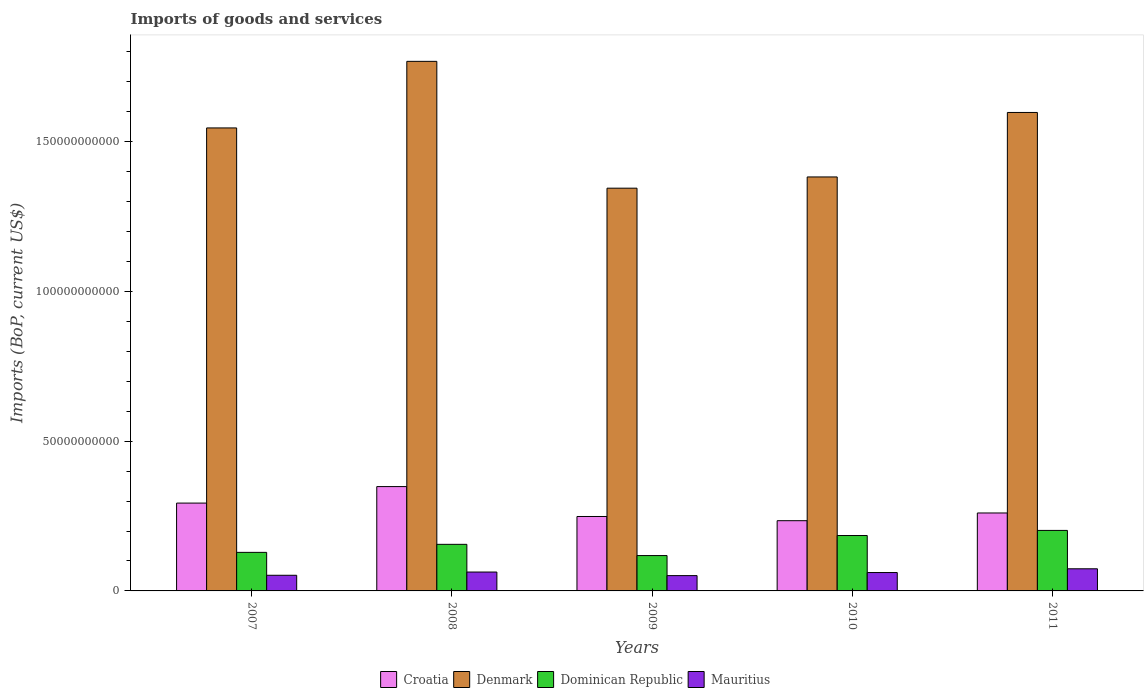Are the number of bars per tick equal to the number of legend labels?
Your response must be concise. Yes. How many bars are there on the 5th tick from the left?
Your answer should be very brief. 4. What is the amount spent on imports in Mauritius in 2011?
Your answer should be very brief. 7.39e+09. Across all years, what is the maximum amount spent on imports in Denmark?
Offer a terse response. 1.77e+11. Across all years, what is the minimum amount spent on imports in Denmark?
Offer a very short reply. 1.34e+11. In which year was the amount spent on imports in Croatia maximum?
Ensure brevity in your answer.  2008. In which year was the amount spent on imports in Denmark minimum?
Offer a very short reply. 2009. What is the total amount spent on imports in Croatia in the graph?
Provide a succinct answer. 1.38e+11. What is the difference between the amount spent on imports in Denmark in 2008 and that in 2011?
Give a very brief answer. 1.71e+1. What is the difference between the amount spent on imports in Dominican Republic in 2007 and the amount spent on imports in Croatia in 2010?
Provide a succinct answer. -1.06e+1. What is the average amount spent on imports in Denmark per year?
Offer a very short reply. 1.53e+11. In the year 2011, what is the difference between the amount spent on imports in Croatia and amount spent on imports in Denmark?
Ensure brevity in your answer.  -1.34e+11. In how many years, is the amount spent on imports in Denmark greater than 10000000000 US$?
Your answer should be compact. 5. What is the ratio of the amount spent on imports in Croatia in 2008 to that in 2010?
Offer a terse response. 1.49. What is the difference between the highest and the second highest amount spent on imports in Croatia?
Provide a succinct answer. 5.50e+09. What is the difference between the highest and the lowest amount spent on imports in Denmark?
Give a very brief answer. 4.23e+1. Is the sum of the amount spent on imports in Denmark in 2007 and 2011 greater than the maximum amount spent on imports in Mauritius across all years?
Your answer should be very brief. Yes. Is it the case that in every year, the sum of the amount spent on imports in Denmark and amount spent on imports in Dominican Republic is greater than the sum of amount spent on imports in Croatia and amount spent on imports in Mauritius?
Ensure brevity in your answer.  No. What does the 4th bar from the left in 2007 represents?
Ensure brevity in your answer.  Mauritius. What does the 1st bar from the right in 2009 represents?
Ensure brevity in your answer.  Mauritius. How many years are there in the graph?
Your answer should be very brief. 5. What is the difference between two consecutive major ticks on the Y-axis?
Provide a succinct answer. 5.00e+1. Are the values on the major ticks of Y-axis written in scientific E-notation?
Offer a terse response. No. Does the graph contain any zero values?
Make the answer very short. No. Where does the legend appear in the graph?
Offer a terse response. Bottom center. How are the legend labels stacked?
Give a very brief answer. Horizontal. What is the title of the graph?
Provide a succinct answer. Imports of goods and services. Does "Cambodia" appear as one of the legend labels in the graph?
Provide a succinct answer. No. What is the label or title of the X-axis?
Provide a succinct answer. Years. What is the label or title of the Y-axis?
Offer a very short reply. Imports (BoP, current US$). What is the Imports (BoP, current US$) in Croatia in 2007?
Your answer should be very brief. 2.93e+1. What is the Imports (BoP, current US$) of Denmark in 2007?
Offer a terse response. 1.55e+11. What is the Imports (BoP, current US$) of Dominican Republic in 2007?
Keep it short and to the point. 1.29e+1. What is the Imports (BoP, current US$) in Mauritius in 2007?
Ensure brevity in your answer.  5.23e+09. What is the Imports (BoP, current US$) of Croatia in 2008?
Your answer should be very brief. 3.48e+1. What is the Imports (BoP, current US$) in Denmark in 2008?
Your response must be concise. 1.77e+11. What is the Imports (BoP, current US$) in Dominican Republic in 2008?
Provide a short and direct response. 1.56e+1. What is the Imports (BoP, current US$) in Mauritius in 2008?
Provide a short and direct response. 6.31e+09. What is the Imports (BoP, current US$) of Croatia in 2009?
Offer a very short reply. 2.48e+1. What is the Imports (BoP, current US$) of Denmark in 2009?
Your answer should be very brief. 1.34e+11. What is the Imports (BoP, current US$) of Dominican Republic in 2009?
Make the answer very short. 1.18e+1. What is the Imports (BoP, current US$) in Mauritius in 2009?
Ensure brevity in your answer.  5.11e+09. What is the Imports (BoP, current US$) in Croatia in 2010?
Offer a terse response. 2.34e+1. What is the Imports (BoP, current US$) of Denmark in 2010?
Provide a succinct answer. 1.38e+11. What is the Imports (BoP, current US$) of Dominican Republic in 2010?
Your response must be concise. 1.85e+1. What is the Imports (BoP, current US$) in Mauritius in 2010?
Ensure brevity in your answer.  6.14e+09. What is the Imports (BoP, current US$) in Croatia in 2011?
Provide a short and direct response. 2.60e+1. What is the Imports (BoP, current US$) of Denmark in 2011?
Offer a very short reply. 1.60e+11. What is the Imports (BoP, current US$) in Dominican Republic in 2011?
Give a very brief answer. 2.02e+1. What is the Imports (BoP, current US$) in Mauritius in 2011?
Provide a short and direct response. 7.39e+09. Across all years, what is the maximum Imports (BoP, current US$) in Croatia?
Your response must be concise. 3.48e+1. Across all years, what is the maximum Imports (BoP, current US$) in Denmark?
Your answer should be compact. 1.77e+11. Across all years, what is the maximum Imports (BoP, current US$) in Dominican Republic?
Offer a very short reply. 2.02e+1. Across all years, what is the maximum Imports (BoP, current US$) of Mauritius?
Your answer should be very brief. 7.39e+09. Across all years, what is the minimum Imports (BoP, current US$) of Croatia?
Your answer should be compact. 2.34e+1. Across all years, what is the minimum Imports (BoP, current US$) in Denmark?
Provide a succinct answer. 1.34e+11. Across all years, what is the minimum Imports (BoP, current US$) in Dominican Republic?
Your response must be concise. 1.18e+1. Across all years, what is the minimum Imports (BoP, current US$) in Mauritius?
Offer a terse response. 5.11e+09. What is the total Imports (BoP, current US$) in Croatia in the graph?
Offer a terse response. 1.38e+11. What is the total Imports (BoP, current US$) in Denmark in the graph?
Make the answer very short. 7.64e+11. What is the total Imports (BoP, current US$) in Dominican Republic in the graph?
Make the answer very short. 7.89e+1. What is the total Imports (BoP, current US$) of Mauritius in the graph?
Provide a short and direct response. 3.02e+1. What is the difference between the Imports (BoP, current US$) in Croatia in 2007 and that in 2008?
Make the answer very short. -5.50e+09. What is the difference between the Imports (BoP, current US$) of Denmark in 2007 and that in 2008?
Your answer should be compact. -2.22e+1. What is the difference between the Imports (BoP, current US$) of Dominican Republic in 2007 and that in 2008?
Your answer should be very brief. -2.68e+09. What is the difference between the Imports (BoP, current US$) of Mauritius in 2007 and that in 2008?
Make the answer very short. -1.08e+09. What is the difference between the Imports (BoP, current US$) of Croatia in 2007 and that in 2009?
Your answer should be compact. 4.48e+09. What is the difference between the Imports (BoP, current US$) of Denmark in 2007 and that in 2009?
Your response must be concise. 2.01e+1. What is the difference between the Imports (BoP, current US$) in Dominican Republic in 2007 and that in 2009?
Offer a very short reply. 1.07e+09. What is the difference between the Imports (BoP, current US$) of Mauritius in 2007 and that in 2009?
Offer a terse response. 1.14e+08. What is the difference between the Imports (BoP, current US$) of Croatia in 2007 and that in 2010?
Offer a very short reply. 5.88e+09. What is the difference between the Imports (BoP, current US$) of Denmark in 2007 and that in 2010?
Your answer should be very brief. 1.64e+1. What is the difference between the Imports (BoP, current US$) in Dominican Republic in 2007 and that in 2010?
Your response must be concise. -5.63e+09. What is the difference between the Imports (BoP, current US$) of Mauritius in 2007 and that in 2010?
Your response must be concise. -9.11e+08. What is the difference between the Imports (BoP, current US$) in Croatia in 2007 and that in 2011?
Provide a succinct answer. 3.30e+09. What is the difference between the Imports (BoP, current US$) of Denmark in 2007 and that in 2011?
Ensure brevity in your answer.  -5.16e+09. What is the difference between the Imports (BoP, current US$) of Dominican Republic in 2007 and that in 2011?
Offer a very short reply. -7.33e+09. What is the difference between the Imports (BoP, current US$) of Mauritius in 2007 and that in 2011?
Offer a terse response. -2.16e+09. What is the difference between the Imports (BoP, current US$) in Croatia in 2008 and that in 2009?
Your response must be concise. 9.98e+09. What is the difference between the Imports (BoP, current US$) in Denmark in 2008 and that in 2009?
Provide a succinct answer. 4.23e+1. What is the difference between the Imports (BoP, current US$) of Dominican Republic in 2008 and that in 2009?
Provide a succinct answer. 3.75e+09. What is the difference between the Imports (BoP, current US$) in Mauritius in 2008 and that in 2009?
Offer a terse response. 1.19e+09. What is the difference between the Imports (BoP, current US$) in Croatia in 2008 and that in 2010?
Provide a short and direct response. 1.14e+1. What is the difference between the Imports (BoP, current US$) of Denmark in 2008 and that in 2010?
Offer a very short reply. 3.86e+1. What is the difference between the Imports (BoP, current US$) of Dominican Republic in 2008 and that in 2010?
Ensure brevity in your answer.  -2.94e+09. What is the difference between the Imports (BoP, current US$) in Mauritius in 2008 and that in 2010?
Keep it short and to the point. 1.70e+08. What is the difference between the Imports (BoP, current US$) of Croatia in 2008 and that in 2011?
Make the answer very short. 8.81e+09. What is the difference between the Imports (BoP, current US$) of Denmark in 2008 and that in 2011?
Provide a short and direct response. 1.71e+1. What is the difference between the Imports (BoP, current US$) of Dominican Republic in 2008 and that in 2011?
Provide a short and direct response. -4.65e+09. What is the difference between the Imports (BoP, current US$) of Mauritius in 2008 and that in 2011?
Ensure brevity in your answer.  -1.08e+09. What is the difference between the Imports (BoP, current US$) in Croatia in 2009 and that in 2010?
Your answer should be very brief. 1.40e+09. What is the difference between the Imports (BoP, current US$) of Denmark in 2009 and that in 2010?
Your response must be concise. -3.75e+09. What is the difference between the Imports (BoP, current US$) of Dominican Republic in 2009 and that in 2010?
Ensure brevity in your answer.  -6.69e+09. What is the difference between the Imports (BoP, current US$) in Mauritius in 2009 and that in 2010?
Your answer should be compact. -1.02e+09. What is the difference between the Imports (BoP, current US$) in Croatia in 2009 and that in 2011?
Provide a short and direct response. -1.18e+09. What is the difference between the Imports (BoP, current US$) in Denmark in 2009 and that in 2011?
Your answer should be compact. -2.53e+1. What is the difference between the Imports (BoP, current US$) of Dominican Republic in 2009 and that in 2011?
Give a very brief answer. -8.40e+09. What is the difference between the Imports (BoP, current US$) in Mauritius in 2009 and that in 2011?
Give a very brief answer. -2.28e+09. What is the difference between the Imports (BoP, current US$) in Croatia in 2010 and that in 2011?
Provide a short and direct response. -2.58e+09. What is the difference between the Imports (BoP, current US$) of Denmark in 2010 and that in 2011?
Make the answer very short. -2.15e+1. What is the difference between the Imports (BoP, current US$) of Dominican Republic in 2010 and that in 2011?
Give a very brief answer. -1.70e+09. What is the difference between the Imports (BoP, current US$) in Mauritius in 2010 and that in 2011?
Ensure brevity in your answer.  -1.25e+09. What is the difference between the Imports (BoP, current US$) of Croatia in 2007 and the Imports (BoP, current US$) of Denmark in 2008?
Offer a terse response. -1.47e+11. What is the difference between the Imports (BoP, current US$) in Croatia in 2007 and the Imports (BoP, current US$) in Dominican Republic in 2008?
Make the answer very short. 1.38e+1. What is the difference between the Imports (BoP, current US$) of Croatia in 2007 and the Imports (BoP, current US$) of Mauritius in 2008?
Your response must be concise. 2.30e+1. What is the difference between the Imports (BoP, current US$) in Denmark in 2007 and the Imports (BoP, current US$) in Dominican Republic in 2008?
Your response must be concise. 1.39e+11. What is the difference between the Imports (BoP, current US$) of Denmark in 2007 and the Imports (BoP, current US$) of Mauritius in 2008?
Provide a short and direct response. 1.48e+11. What is the difference between the Imports (BoP, current US$) of Dominican Republic in 2007 and the Imports (BoP, current US$) of Mauritius in 2008?
Give a very brief answer. 6.56e+09. What is the difference between the Imports (BoP, current US$) in Croatia in 2007 and the Imports (BoP, current US$) in Denmark in 2009?
Offer a terse response. -1.05e+11. What is the difference between the Imports (BoP, current US$) of Croatia in 2007 and the Imports (BoP, current US$) of Dominican Republic in 2009?
Offer a terse response. 1.75e+1. What is the difference between the Imports (BoP, current US$) in Croatia in 2007 and the Imports (BoP, current US$) in Mauritius in 2009?
Provide a short and direct response. 2.42e+1. What is the difference between the Imports (BoP, current US$) in Denmark in 2007 and the Imports (BoP, current US$) in Dominican Republic in 2009?
Give a very brief answer. 1.43e+11. What is the difference between the Imports (BoP, current US$) in Denmark in 2007 and the Imports (BoP, current US$) in Mauritius in 2009?
Your response must be concise. 1.49e+11. What is the difference between the Imports (BoP, current US$) of Dominican Republic in 2007 and the Imports (BoP, current US$) of Mauritius in 2009?
Keep it short and to the point. 7.76e+09. What is the difference between the Imports (BoP, current US$) of Croatia in 2007 and the Imports (BoP, current US$) of Denmark in 2010?
Provide a short and direct response. -1.09e+11. What is the difference between the Imports (BoP, current US$) of Croatia in 2007 and the Imports (BoP, current US$) of Dominican Republic in 2010?
Your answer should be very brief. 1.08e+1. What is the difference between the Imports (BoP, current US$) of Croatia in 2007 and the Imports (BoP, current US$) of Mauritius in 2010?
Ensure brevity in your answer.  2.32e+1. What is the difference between the Imports (BoP, current US$) in Denmark in 2007 and the Imports (BoP, current US$) in Dominican Republic in 2010?
Provide a succinct answer. 1.36e+11. What is the difference between the Imports (BoP, current US$) in Denmark in 2007 and the Imports (BoP, current US$) in Mauritius in 2010?
Keep it short and to the point. 1.48e+11. What is the difference between the Imports (BoP, current US$) of Dominican Republic in 2007 and the Imports (BoP, current US$) of Mauritius in 2010?
Provide a succinct answer. 6.73e+09. What is the difference between the Imports (BoP, current US$) in Croatia in 2007 and the Imports (BoP, current US$) in Denmark in 2011?
Offer a terse response. -1.30e+11. What is the difference between the Imports (BoP, current US$) in Croatia in 2007 and the Imports (BoP, current US$) in Dominican Republic in 2011?
Provide a succinct answer. 9.13e+09. What is the difference between the Imports (BoP, current US$) of Croatia in 2007 and the Imports (BoP, current US$) of Mauritius in 2011?
Give a very brief answer. 2.19e+1. What is the difference between the Imports (BoP, current US$) of Denmark in 2007 and the Imports (BoP, current US$) of Dominican Republic in 2011?
Provide a short and direct response. 1.34e+11. What is the difference between the Imports (BoP, current US$) in Denmark in 2007 and the Imports (BoP, current US$) in Mauritius in 2011?
Make the answer very short. 1.47e+11. What is the difference between the Imports (BoP, current US$) in Dominican Republic in 2007 and the Imports (BoP, current US$) in Mauritius in 2011?
Give a very brief answer. 5.48e+09. What is the difference between the Imports (BoP, current US$) in Croatia in 2008 and the Imports (BoP, current US$) in Denmark in 2009?
Offer a very short reply. -9.96e+1. What is the difference between the Imports (BoP, current US$) of Croatia in 2008 and the Imports (BoP, current US$) of Dominican Republic in 2009?
Ensure brevity in your answer.  2.30e+1. What is the difference between the Imports (BoP, current US$) of Croatia in 2008 and the Imports (BoP, current US$) of Mauritius in 2009?
Your answer should be very brief. 2.97e+1. What is the difference between the Imports (BoP, current US$) of Denmark in 2008 and the Imports (BoP, current US$) of Dominican Republic in 2009?
Make the answer very short. 1.65e+11. What is the difference between the Imports (BoP, current US$) of Denmark in 2008 and the Imports (BoP, current US$) of Mauritius in 2009?
Your answer should be compact. 1.72e+11. What is the difference between the Imports (BoP, current US$) in Dominican Republic in 2008 and the Imports (BoP, current US$) in Mauritius in 2009?
Make the answer very short. 1.04e+1. What is the difference between the Imports (BoP, current US$) in Croatia in 2008 and the Imports (BoP, current US$) in Denmark in 2010?
Your response must be concise. -1.03e+11. What is the difference between the Imports (BoP, current US$) in Croatia in 2008 and the Imports (BoP, current US$) in Dominican Republic in 2010?
Give a very brief answer. 1.63e+1. What is the difference between the Imports (BoP, current US$) of Croatia in 2008 and the Imports (BoP, current US$) of Mauritius in 2010?
Your answer should be very brief. 2.87e+1. What is the difference between the Imports (BoP, current US$) in Denmark in 2008 and the Imports (BoP, current US$) in Dominican Republic in 2010?
Offer a very short reply. 1.58e+11. What is the difference between the Imports (BoP, current US$) in Denmark in 2008 and the Imports (BoP, current US$) in Mauritius in 2010?
Your answer should be compact. 1.71e+11. What is the difference between the Imports (BoP, current US$) of Dominican Republic in 2008 and the Imports (BoP, current US$) of Mauritius in 2010?
Your answer should be compact. 9.42e+09. What is the difference between the Imports (BoP, current US$) in Croatia in 2008 and the Imports (BoP, current US$) in Denmark in 2011?
Make the answer very short. -1.25e+11. What is the difference between the Imports (BoP, current US$) of Croatia in 2008 and the Imports (BoP, current US$) of Dominican Republic in 2011?
Your response must be concise. 1.46e+1. What is the difference between the Imports (BoP, current US$) in Croatia in 2008 and the Imports (BoP, current US$) in Mauritius in 2011?
Keep it short and to the point. 2.74e+1. What is the difference between the Imports (BoP, current US$) of Denmark in 2008 and the Imports (BoP, current US$) of Dominican Republic in 2011?
Offer a very short reply. 1.57e+11. What is the difference between the Imports (BoP, current US$) of Denmark in 2008 and the Imports (BoP, current US$) of Mauritius in 2011?
Offer a very short reply. 1.69e+11. What is the difference between the Imports (BoP, current US$) of Dominican Republic in 2008 and the Imports (BoP, current US$) of Mauritius in 2011?
Your answer should be compact. 8.17e+09. What is the difference between the Imports (BoP, current US$) in Croatia in 2009 and the Imports (BoP, current US$) in Denmark in 2010?
Keep it short and to the point. -1.13e+11. What is the difference between the Imports (BoP, current US$) of Croatia in 2009 and the Imports (BoP, current US$) of Dominican Republic in 2010?
Keep it short and to the point. 6.35e+09. What is the difference between the Imports (BoP, current US$) in Croatia in 2009 and the Imports (BoP, current US$) in Mauritius in 2010?
Offer a terse response. 1.87e+1. What is the difference between the Imports (BoP, current US$) in Denmark in 2009 and the Imports (BoP, current US$) in Dominican Republic in 2010?
Your answer should be very brief. 1.16e+11. What is the difference between the Imports (BoP, current US$) of Denmark in 2009 and the Imports (BoP, current US$) of Mauritius in 2010?
Ensure brevity in your answer.  1.28e+11. What is the difference between the Imports (BoP, current US$) of Dominican Republic in 2009 and the Imports (BoP, current US$) of Mauritius in 2010?
Provide a succinct answer. 5.67e+09. What is the difference between the Imports (BoP, current US$) of Croatia in 2009 and the Imports (BoP, current US$) of Denmark in 2011?
Provide a short and direct response. -1.35e+11. What is the difference between the Imports (BoP, current US$) in Croatia in 2009 and the Imports (BoP, current US$) in Dominican Republic in 2011?
Provide a succinct answer. 4.65e+09. What is the difference between the Imports (BoP, current US$) of Croatia in 2009 and the Imports (BoP, current US$) of Mauritius in 2011?
Your answer should be compact. 1.75e+1. What is the difference between the Imports (BoP, current US$) in Denmark in 2009 and the Imports (BoP, current US$) in Dominican Republic in 2011?
Offer a very short reply. 1.14e+11. What is the difference between the Imports (BoP, current US$) in Denmark in 2009 and the Imports (BoP, current US$) in Mauritius in 2011?
Ensure brevity in your answer.  1.27e+11. What is the difference between the Imports (BoP, current US$) in Dominican Republic in 2009 and the Imports (BoP, current US$) in Mauritius in 2011?
Give a very brief answer. 4.42e+09. What is the difference between the Imports (BoP, current US$) in Croatia in 2010 and the Imports (BoP, current US$) in Denmark in 2011?
Offer a terse response. -1.36e+11. What is the difference between the Imports (BoP, current US$) of Croatia in 2010 and the Imports (BoP, current US$) of Dominican Republic in 2011?
Keep it short and to the point. 3.24e+09. What is the difference between the Imports (BoP, current US$) of Croatia in 2010 and the Imports (BoP, current US$) of Mauritius in 2011?
Your answer should be very brief. 1.61e+1. What is the difference between the Imports (BoP, current US$) in Denmark in 2010 and the Imports (BoP, current US$) in Dominican Republic in 2011?
Keep it short and to the point. 1.18e+11. What is the difference between the Imports (BoP, current US$) in Denmark in 2010 and the Imports (BoP, current US$) in Mauritius in 2011?
Provide a succinct answer. 1.31e+11. What is the difference between the Imports (BoP, current US$) of Dominican Republic in 2010 and the Imports (BoP, current US$) of Mauritius in 2011?
Offer a terse response. 1.11e+1. What is the average Imports (BoP, current US$) in Croatia per year?
Make the answer very short. 2.77e+1. What is the average Imports (BoP, current US$) in Denmark per year?
Your answer should be compact. 1.53e+11. What is the average Imports (BoP, current US$) of Dominican Republic per year?
Your answer should be compact. 1.58e+1. What is the average Imports (BoP, current US$) of Mauritius per year?
Give a very brief answer. 6.03e+09. In the year 2007, what is the difference between the Imports (BoP, current US$) in Croatia and Imports (BoP, current US$) in Denmark?
Your response must be concise. -1.25e+11. In the year 2007, what is the difference between the Imports (BoP, current US$) in Croatia and Imports (BoP, current US$) in Dominican Republic?
Your answer should be compact. 1.65e+1. In the year 2007, what is the difference between the Imports (BoP, current US$) in Croatia and Imports (BoP, current US$) in Mauritius?
Ensure brevity in your answer.  2.41e+1. In the year 2007, what is the difference between the Imports (BoP, current US$) of Denmark and Imports (BoP, current US$) of Dominican Republic?
Make the answer very short. 1.42e+11. In the year 2007, what is the difference between the Imports (BoP, current US$) in Denmark and Imports (BoP, current US$) in Mauritius?
Keep it short and to the point. 1.49e+11. In the year 2007, what is the difference between the Imports (BoP, current US$) of Dominican Republic and Imports (BoP, current US$) of Mauritius?
Keep it short and to the point. 7.64e+09. In the year 2008, what is the difference between the Imports (BoP, current US$) in Croatia and Imports (BoP, current US$) in Denmark?
Keep it short and to the point. -1.42e+11. In the year 2008, what is the difference between the Imports (BoP, current US$) of Croatia and Imports (BoP, current US$) of Dominican Republic?
Keep it short and to the point. 1.93e+1. In the year 2008, what is the difference between the Imports (BoP, current US$) of Croatia and Imports (BoP, current US$) of Mauritius?
Provide a succinct answer. 2.85e+1. In the year 2008, what is the difference between the Imports (BoP, current US$) of Denmark and Imports (BoP, current US$) of Dominican Republic?
Provide a succinct answer. 1.61e+11. In the year 2008, what is the difference between the Imports (BoP, current US$) of Denmark and Imports (BoP, current US$) of Mauritius?
Offer a very short reply. 1.71e+11. In the year 2008, what is the difference between the Imports (BoP, current US$) in Dominican Republic and Imports (BoP, current US$) in Mauritius?
Give a very brief answer. 9.25e+09. In the year 2009, what is the difference between the Imports (BoP, current US$) of Croatia and Imports (BoP, current US$) of Denmark?
Provide a short and direct response. -1.10e+11. In the year 2009, what is the difference between the Imports (BoP, current US$) of Croatia and Imports (BoP, current US$) of Dominican Republic?
Your answer should be compact. 1.30e+1. In the year 2009, what is the difference between the Imports (BoP, current US$) in Croatia and Imports (BoP, current US$) in Mauritius?
Provide a succinct answer. 1.97e+1. In the year 2009, what is the difference between the Imports (BoP, current US$) in Denmark and Imports (BoP, current US$) in Dominican Republic?
Your answer should be compact. 1.23e+11. In the year 2009, what is the difference between the Imports (BoP, current US$) in Denmark and Imports (BoP, current US$) in Mauritius?
Make the answer very short. 1.29e+11. In the year 2009, what is the difference between the Imports (BoP, current US$) of Dominican Republic and Imports (BoP, current US$) of Mauritius?
Keep it short and to the point. 6.69e+09. In the year 2010, what is the difference between the Imports (BoP, current US$) of Croatia and Imports (BoP, current US$) of Denmark?
Provide a succinct answer. -1.15e+11. In the year 2010, what is the difference between the Imports (BoP, current US$) in Croatia and Imports (BoP, current US$) in Dominican Republic?
Keep it short and to the point. 4.95e+09. In the year 2010, what is the difference between the Imports (BoP, current US$) in Croatia and Imports (BoP, current US$) in Mauritius?
Your answer should be very brief. 1.73e+1. In the year 2010, what is the difference between the Imports (BoP, current US$) in Denmark and Imports (BoP, current US$) in Dominican Republic?
Provide a succinct answer. 1.20e+11. In the year 2010, what is the difference between the Imports (BoP, current US$) of Denmark and Imports (BoP, current US$) of Mauritius?
Your answer should be very brief. 1.32e+11. In the year 2010, what is the difference between the Imports (BoP, current US$) in Dominican Republic and Imports (BoP, current US$) in Mauritius?
Offer a very short reply. 1.24e+1. In the year 2011, what is the difference between the Imports (BoP, current US$) of Croatia and Imports (BoP, current US$) of Denmark?
Ensure brevity in your answer.  -1.34e+11. In the year 2011, what is the difference between the Imports (BoP, current US$) in Croatia and Imports (BoP, current US$) in Dominican Republic?
Give a very brief answer. 5.82e+09. In the year 2011, what is the difference between the Imports (BoP, current US$) of Croatia and Imports (BoP, current US$) of Mauritius?
Your response must be concise. 1.86e+1. In the year 2011, what is the difference between the Imports (BoP, current US$) in Denmark and Imports (BoP, current US$) in Dominican Republic?
Keep it short and to the point. 1.40e+11. In the year 2011, what is the difference between the Imports (BoP, current US$) of Denmark and Imports (BoP, current US$) of Mauritius?
Your answer should be compact. 1.52e+11. In the year 2011, what is the difference between the Imports (BoP, current US$) of Dominican Republic and Imports (BoP, current US$) of Mauritius?
Your response must be concise. 1.28e+1. What is the ratio of the Imports (BoP, current US$) in Croatia in 2007 to that in 2008?
Provide a succinct answer. 0.84. What is the ratio of the Imports (BoP, current US$) in Denmark in 2007 to that in 2008?
Give a very brief answer. 0.87. What is the ratio of the Imports (BoP, current US$) in Dominican Republic in 2007 to that in 2008?
Offer a very short reply. 0.83. What is the ratio of the Imports (BoP, current US$) in Mauritius in 2007 to that in 2008?
Your answer should be compact. 0.83. What is the ratio of the Imports (BoP, current US$) in Croatia in 2007 to that in 2009?
Offer a very short reply. 1.18. What is the ratio of the Imports (BoP, current US$) in Denmark in 2007 to that in 2009?
Your answer should be compact. 1.15. What is the ratio of the Imports (BoP, current US$) in Dominican Republic in 2007 to that in 2009?
Make the answer very short. 1.09. What is the ratio of the Imports (BoP, current US$) of Mauritius in 2007 to that in 2009?
Give a very brief answer. 1.02. What is the ratio of the Imports (BoP, current US$) in Croatia in 2007 to that in 2010?
Give a very brief answer. 1.25. What is the ratio of the Imports (BoP, current US$) in Denmark in 2007 to that in 2010?
Make the answer very short. 1.12. What is the ratio of the Imports (BoP, current US$) of Dominican Republic in 2007 to that in 2010?
Provide a short and direct response. 0.7. What is the ratio of the Imports (BoP, current US$) in Mauritius in 2007 to that in 2010?
Offer a very short reply. 0.85. What is the ratio of the Imports (BoP, current US$) in Croatia in 2007 to that in 2011?
Give a very brief answer. 1.13. What is the ratio of the Imports (BoP, current US$) of Denmark in 2007 to that in 2011?
Provide a succinct answer. 0.97. What is the ratio of the Imports (BoP, current US$) of Dominican Republic in 2007 to that in 2011?
Your answer should be very brief. 0.64. What is the ratio of the Imports (BoP, current US$) of Mauritius in 2007 to that in 2011?
Your answer should be very brief. 0.71. What is the ratio of the Imports (BoP, current US$) of Croatia in 2008 to that in 2009?
Your answer should be compact. 1.4. What is the ratio of the Imports (BoP, current US$) of Denmark in 2008 to that in 2009?
Your answer should be compact. 1.31. What is the ratio of the Imports (BoP, current US$) of Dominican Republic in 2008 to that in 2009?
Offer a terse response. 1.32. What is the ratio of the Imports (BoP, current US$) of Mauritius in 2008 to that in 2009?
Make the answer very short. 1.23. What is the ratio of the Imports (BoP, current US$) of Croatia in 2008 to that in 2010?
Ensure brevity in your answer.  1.49. What is the ratio of the Imports (BoP, current US$) in Denmark in 2008 to that in 2010?
Your answer should be very brief. 1.28. What is the ratio of the Imports (BoP, current US$) in Dominican Republic in 2008 to that in 2010?
Keep it short and to the point. 0.84. What is the ratio of the Imports (BoP, current US$) in Mauritius in 2008 to that in 2010?
Your answer should be very brief. 1.03. What is the ratio of the Imports (BoP, current US$) in Croatia in 2008 to that in 2011?
Offer a very short reply. 1.34. What is the ratio of the Imports (BoP, current US$) of Denmark in 2008 to that in 2011?
Offer a very short reply. 1.11. What is the ratio of the Imports (BoP, current US$) of Dominican Republic in 2008 to that in 2011?
Provide a short and direct response. 0.77. What is the ratio of the Imports (BoP, current US$) of Mauritius in 2008 to that in 2011?
Your response must be concise. 0.85. What is the ratio of the Imports (BoP, current US$) in Croatia in 2009 to that in 2010?
Your answer should be compact. 1.06. What is the ratio of the Imports (BoP, current US$) of Denmark in 2009 to that in 2010?
Make the answer very short. 0.97. What is the ratio of the Imports (BoP, current US$) of Dominican Republic in 2009 to that in 2010?
Offer a very short reply. 0.64. What is the ratio of the Imports (BoP, current US$) in Mauritius in 2009 to that in 2010?
Offer a very short reply. 0.83. What is the ratio of the Imports (BoP, current US$) in Croatia in 2009 to that in 2011?
Your answer should be very brief. 0.95. What is the ratio of the Imports (BoP, current US$) of Denmark in 2009 to that in 2011?
Ensure brevity in your answer.  0.84. What is the ratio of the Imports (BoP, current US$) in Dominican Republic in 2009 to that in 2011?
Ensure brevity in your answer.  0.58. What is the ratio of the Imports (BoP, current US$) in Mauritius in 2009 to that in 2011?
Provide a short and direct response. 0.69. What is the ratio of the Imports (BoP, current US$) of Croatia in 2010 to that in 2011?
Ensure brevity in your answer.  0.9. What is the ratio of the Imports (BoP, current US$) in Denmark in 2010 to that in 2011?
Offer a terse response. 0.87. What is the ratio of the Imports (BoP, current US$) of Dominican Republic in 2010 to that in 2011?
Your answer should be compact. 0.92. What is the ratio of the Imports (BoP, current US$) of Mauritius in 2010 to that in 2011?
Ensure brevity in your answer.  0.83. What is the difference between the highest and the second highest Imports (BoP, current US$) in Croatia?
Your answer should be very brief. 5.50e+09. What is the difference between the highest and the second highest Imports (BoP, current US$) of Denmark?
Offer a terse response. 1.71e+1. What is the difference between the highest and the second highest Imports (BoP, current US$) of Dominican Republic?
Give a very brief answer. 1.70e+09. What is the difference between the highest and the second highest Imports (BoP, current US$) in Mauritius?
Offer a very short reply. 1.08e+09. What is the difference between the highest and the lowest Imports (BoP, current US$) in Croatia?
Keep it short and to the point. 1.14e+1. What is the difference between the highest and the lowest Imports (BoP, current US$) in Denmark?
Give a very brief answer. 4.23e+1. What is the difference between the highest and the lowest Imports (BoP, current US$) in Dominican Republic?
Keep it short and to the point. 8.40e+09. What is the difference between the highest and the lowest Imports (BoP, current US$) in Mauritius?
Provide a succinct answer. 2.28e+09. 